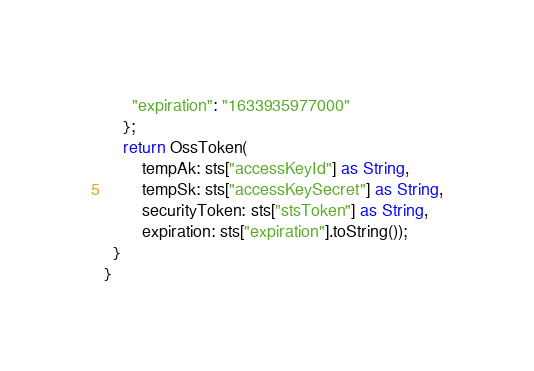Convert code to text. <code><loc_0><loc_0><loc_500><loc_500><_Dart_>      "expiration": "1633935977000"
    };
    return OssToken(
        tempAk: sts["accessKeyId"] as String,
        tempSk: sts["accessKeySecret"] as String,
        securityToken: sts["stsToken"] as String,
        expiration: sts["expiration"].toString());
  }
}
</code> 